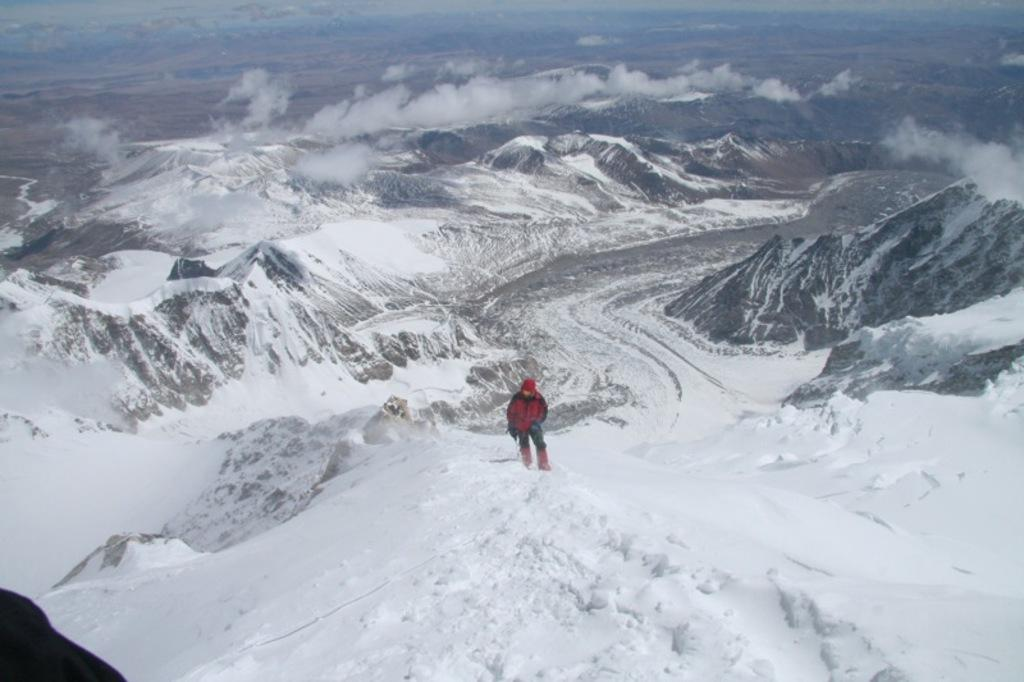What is the main subject of the image? There is a person walking in the center of the image. What is the surface the person is walking on? The person is walking on snow. What can be seen in the background of the image? There is snow on the ground, smoke, and mountains covered in snow in the background of the image. What type of wing can be seen on the police officer's uniform in the image? There is no police officer or wing present in the image. 